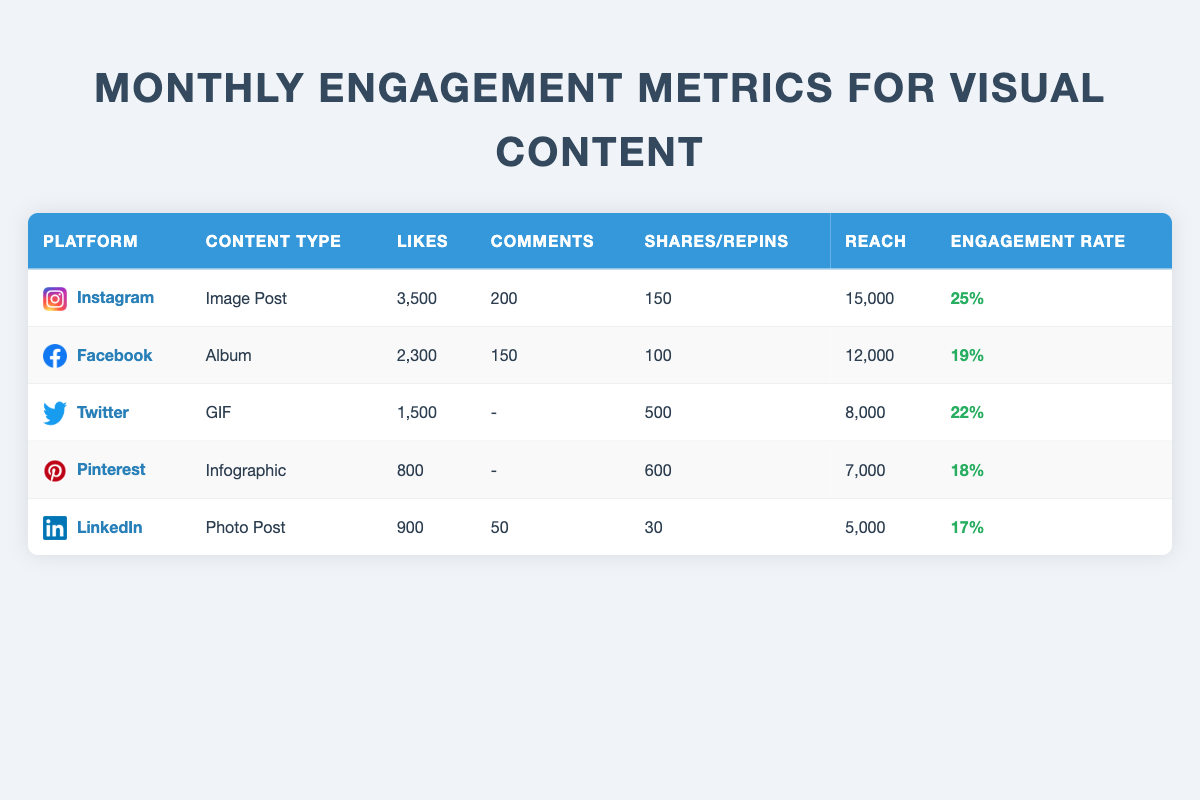What is the engagement rate for Instagram content? The engagement rate for Instagram is listed directly in the table, which states it is 25%.
Answer: 25% Which platform has the highest number of likes for visual content? By examining the "Likes" column, Instagram has the highest value at 3,500.
Answer: Instagram How many total shares and saves did the visual content receive across all platforms? We sum the shares and saves from each platform: Instagram (150 shares) + Facebook (100 shares) + Twitter (500 shares) + Pinterest (600 repins) + LinkedIn (30 shares) = 1380 total shares and saves.
Answer: 1380 Is the engagement rate higher for Facebook or LinkedIn? Facebook has an engagement rate of 19%, while LinkedIn's engagement rate is 17%. Since 19% is greater than 17%, Facebook has a higher engagement rate.
Answer: Yes What is the average reach of the visual content across all platforms? The reach values are: Instagram (15,000) + Facebook (12,000) + Twitter (8,000) + Pinterest (7,000) + LinkedIn (5,000). The total reach is 47,000; dividing by the 5 platforms gives an average reach of 9,400.
Answer: 9,400 Which content type received the least engagement (likes, comments, shares) overall? Looking at the overall engagement, we identify LinkedIn's Photo Post with 900 likes, 50 comments, and 30 shares, leading to the least total engagement compared to the other types.
Answer: LinkedIn Photo Post How many more comments did Instagram receive compared to Pinterest? Instagram received 200 comments, while Pinterest had no comments (indicated by a hyphen) which counts as 0. 200 - 0 = 200.
Answer: 200 Which platform had the least reach and what was that reach? Pinterest has the least reach at 7,000, which can be identified directly from the "Reach" column in the table.
Answer: 7,000 